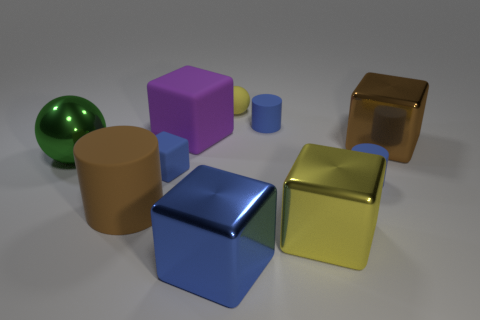Are any metal things visible?
Your response must be concise. Yes. What color is the small matte thing that is both behind the green metal sphere and to the right of the tiny sphere?
Offer a very short reply. Blue. There is a blue block that is behind the brown matte cylinder; is it the same size as the yellow thing behind the big purple matte block?
Provide a succinct answer. Yes. How many other things are the same size as the yellow shiny block?
Make the answer very short. 5. There is a sphere to the right of the green shiny sphere; how many yellow metal cubes are behind it?
Your response must be concise. 0. Is the number of big brown objects to the left of the large brown metal object less than the number of small yellow rubber things?
Your answer should be very brief. No. There is a small blue thing left of the tiny rubber thing behind the tiny matte cylinder that is behind the small blue rubber cube; what is its shape?
Your answer should be compact. Cube. Do the large purple rubber thing and the large yellow thing have the same shape?
Ensure brevity in your answer.  Yes. What number of other things are the same shape as the large blue object?
Your answer should be compact. 4. There is a shiny sphere that is the same size as the purple matte block; what is its color?
Your answer should be very brief. Green. 